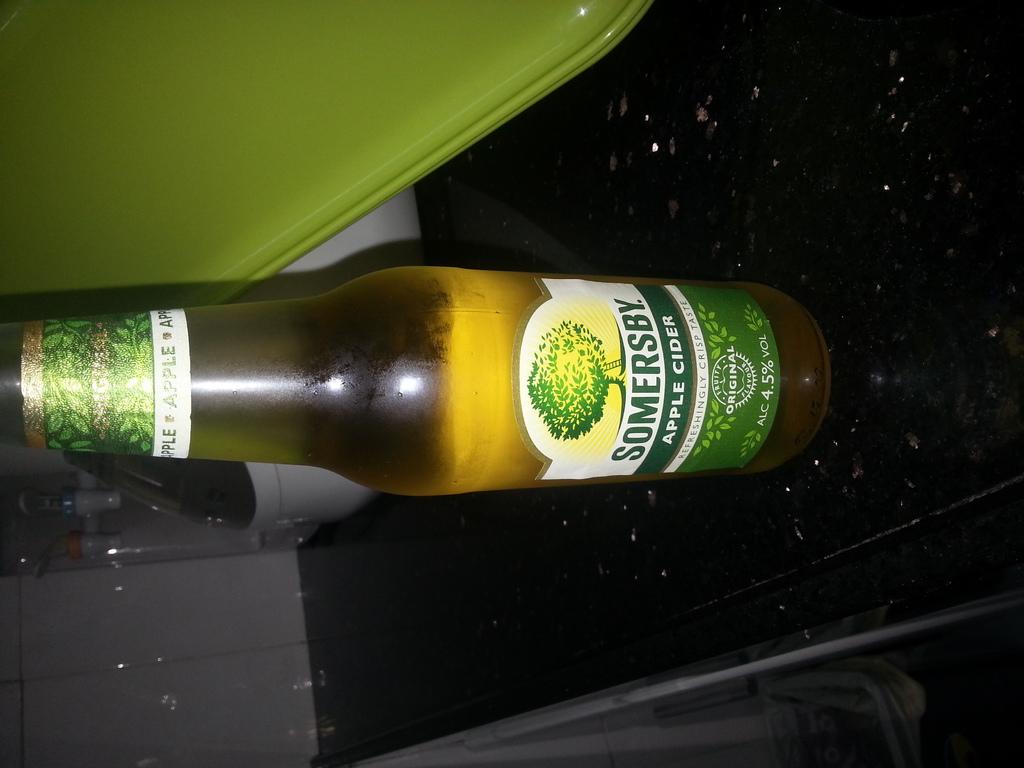What kind of cider is this?
Provide a short and direct response. Apple. Who makes this cider?
Keep it short and to the point. Somersby. 